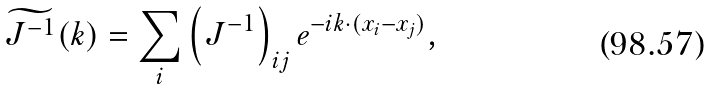Convert formula to latex. <formula><loc_0><loc_0><loc_500><loc_500>\widetilde { J ^ { - 1 } } ( { k } ) = \sum _ { i } \left ( J ^ { - 1 } \right ) _ { i j } e ^ { - i { k } \cdot ( { x } _ { i } - { x } _ { j } ) } ,</formula> 